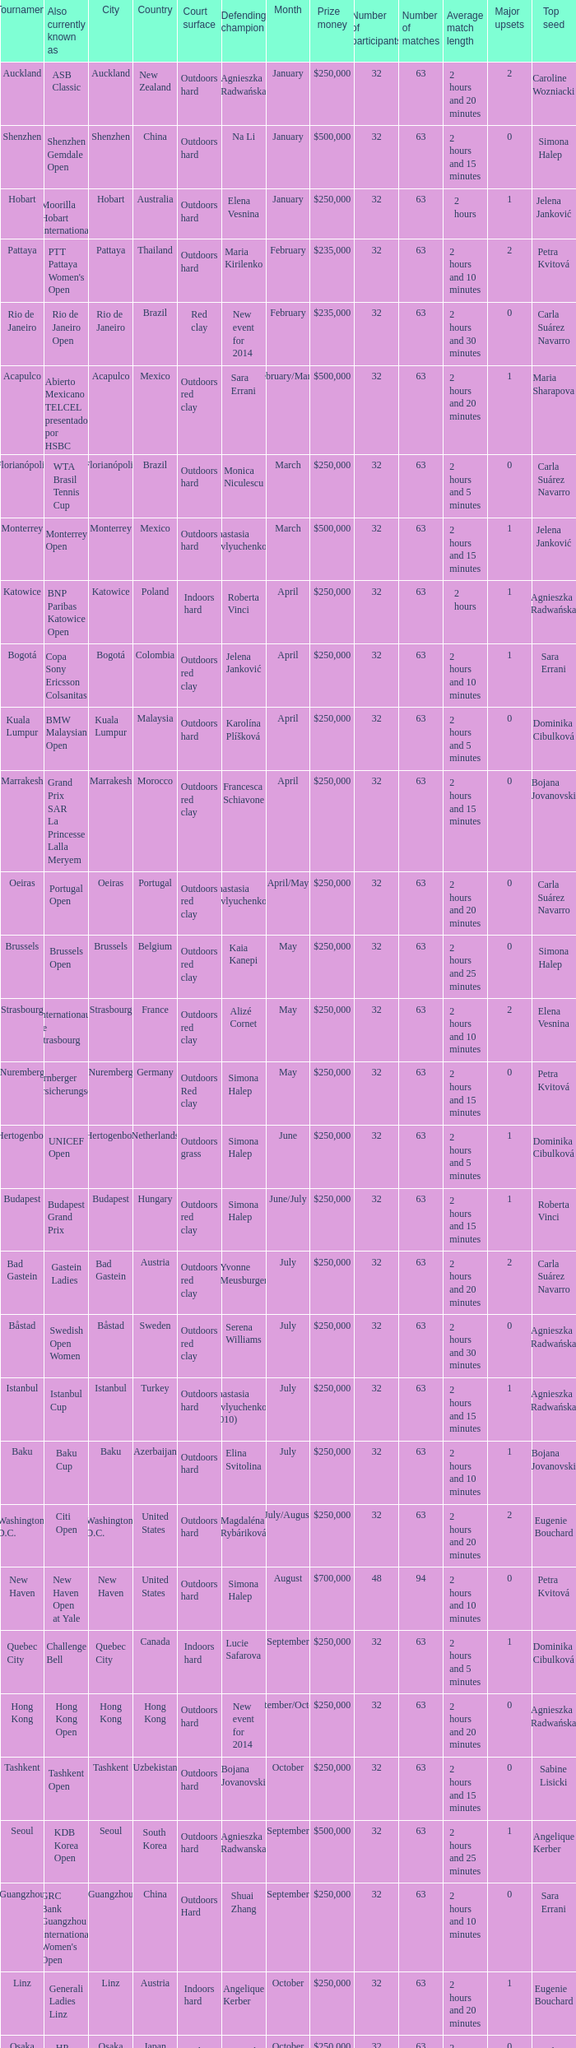What tournament is in katowice? Katowice. 